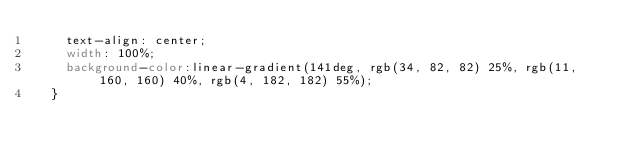<code> <loc_0><loc_0><loc_500><loc_500><_CSS_>    text-align: center;
    width: 100%;
    background-color:linear-gradient(141deg, rgb(34, 82, 82) 25%, rgb(11, 160, 160) 40%, rgb(4, 182, 182) 55%);
  }
</code> 